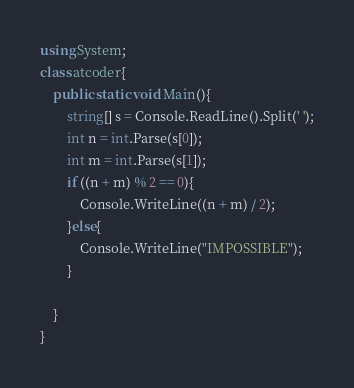<code> <loc_0><loc_0><loc_500><loc_500><_C#_>using System;
class atcoder{
    public static void Main(){
        string[] s = Console.ReadLine().Split(' ');
        int n = int.Parse(s[0]);
        int m = int.Parse(s[1]);
        if ((n + m) % 2 == 0){
            Console.WriteLine((n + m) / 2);
        }else{
            Console.WriteLine("IMPOSSIBLE");
        }

    }
}</code> 